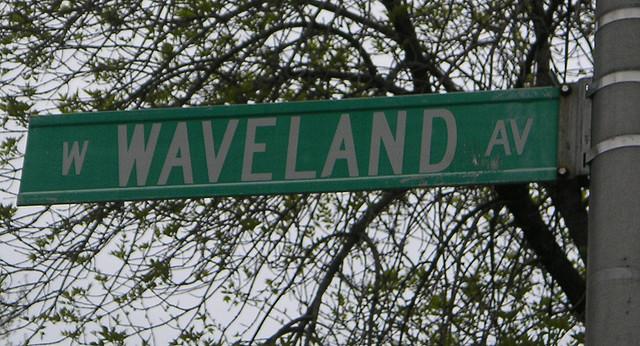What avenue is this?
Write a very short answer. Waveland. What color is the sign?
Answer briefly. Green. What color is the street sign pole?
Quick response, please. Gray. What does the sign say?
Keep it brief. W waveland ave. What color are the letters on the sign?
Give a very brief answer. White. What is the name of the road that starts with a W?
Keep it brief. Waveland. What color is the sign background?
Be succinct. Green. What color is the street sign?
Write a very short answer. Green. 